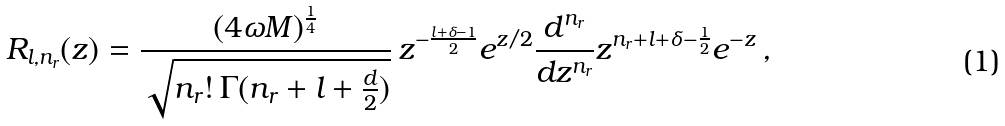<formula> <loc_0><loc_0><loc_500><loc_500>R _ { l , n _ { r } } ( z ) = \frac { ( 4 \omega M ) ^ { \frac { 1 } { 4 } } } { \sqrt { n _ { r } ! \, \Gamma ( n _ { r } + l + \frac { d } { 2 } ) } } \, z ^ { - \frac { l + \delta - 1 } { 2 } } e ^ { z / 2 } \frac { d ^ { n _ { r } } } { d z ^ { n _ { r } } } z ^ { n _ { r } + l + \delta - \frac { 1 } { 2 } } e ^ { - z } \, ,</formula> 